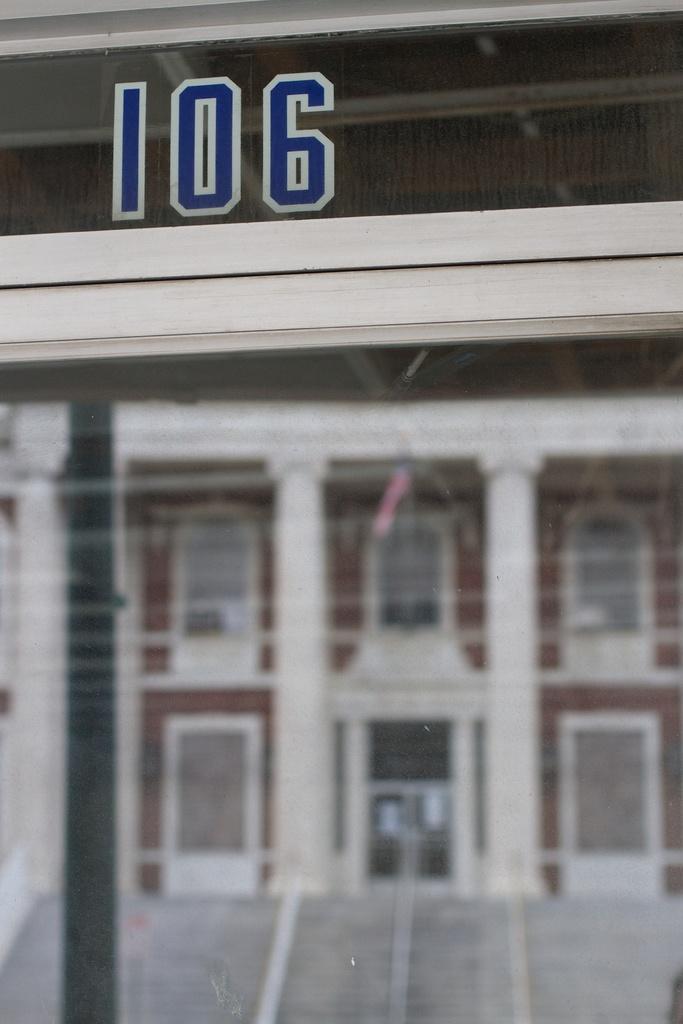What building number is above this door?
Give a very brief answer. 106. 